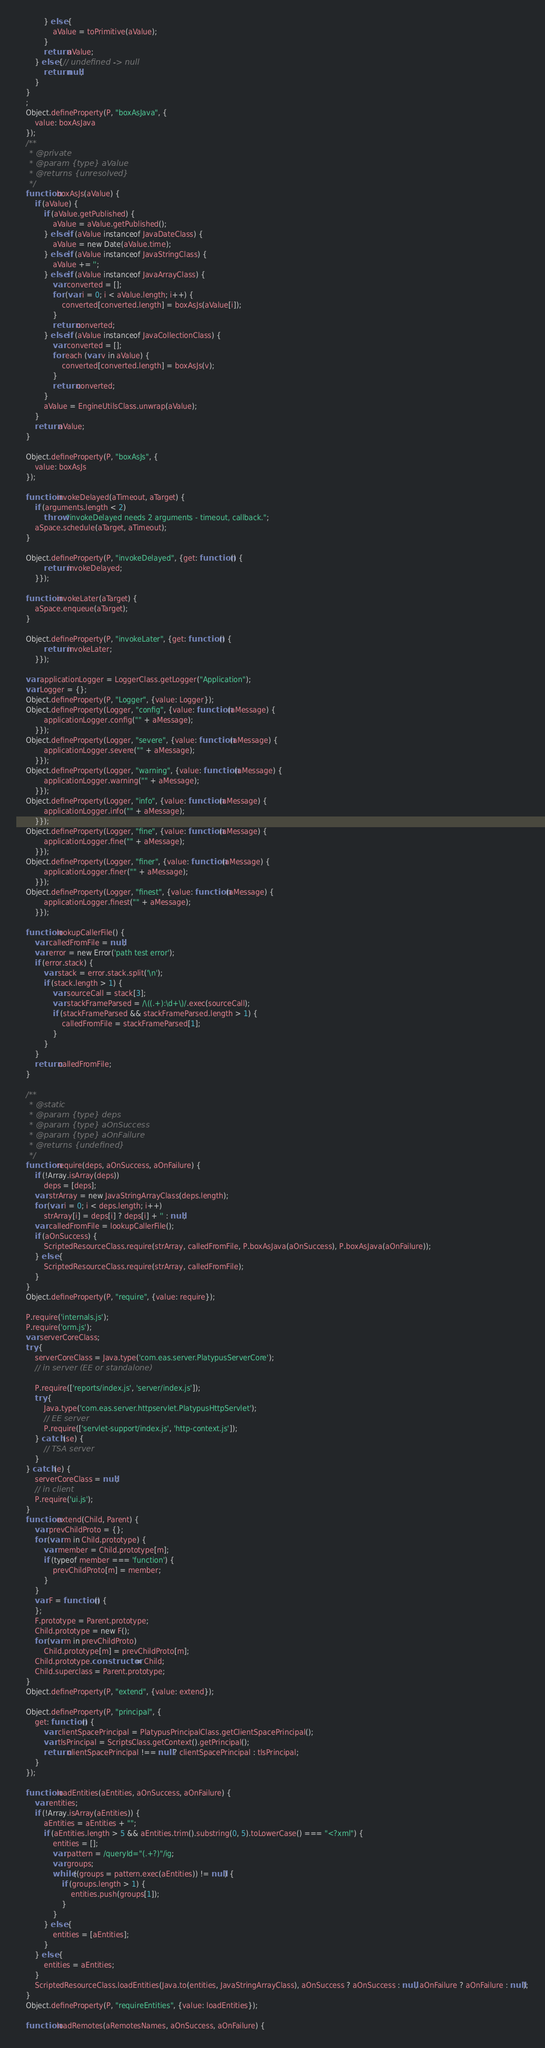<code> <loc_0><loc_0><loc_500><loc_500><_JavaScript_>            } else {
                aValue = toPrimitive(aValue);
            }
            return aValue;
        } else {// undefined -> null
            return null;
        }
    }
    ;
    Object.defineProperty(P, "boxAsJava", {
        value: boxAsJava
    });
    /**
     * @private
     * @param {type} aValue
     * @returns {unresolved}
     */
    function boxAsJs(aValue) {
        if (aValue) {
            if (aValue.getPublished) {
                aValue = aValue.getPublished();
            } else if (aValue instanceof JavaDateClass) {
                aValue = new Date(aValue.time);
            } else if (aValue instanceof JavaStringClass) {
                aValue += '';
            } else if (aValue instanceof JavaArrayClass) {
                var converted = [];
                for (var i = 0; i < aValue.length; i++) {
                    converted[converted.length] = boxAsJs(aValue[i]);
                }
                return converted;
            } else if (aValue instanceof JavaCollectionClass) {
                var converted = [];
                for each (var v in aValue) {
                    converted[converted.length] = boxAsJs(v);
                }
                return converted;
            }
            aValue = EngineUtilsClass.unwrap(aValue);
        }
        return aValue;
    }

    Object.defineProperty(P, "boxAsJs", {
        value: boxAsJs
    });

    function invokeDelayed(aTimeout, aTarget) {
        if (arguments.length < 2)
            throw "invokeDelayed needs 2 arguments - timeout, callback.";
        aSpace.schedule(aTarget, aTimeout);
    }

    Object.defineProperty(P, "invokeDelayed", {get: function () {
            return invokeDelayed;
        }});

    function invokeLater(aTarget) {
        aSpace.enqueue(aTarget);
    }

    Object.defineProperty(P, "invokeLater", {get: function () {
            return invokeLater;
        }});

    var applicationLogger = LoggerClass.getLogger("Application");
    var Logger = {};
    Object.defineProperty(P, "Logger", {value: Logger});
    Object.defineProperty(Logger, "config", {value: function (aMessage) {
            applicationLogger.config("" + aMessage);
        }});
    Object.defineProperty(Logger, "severe", {value: function (aMessage) {
            applicationLogger.severe("" + aMessage);
        }});
    Object.defineProperty(Logger, "warning", {value: function (aMessage) {
            applicationLogger.warning("" + aMessage);
        }});
    Object.defineProperty(Logger, "info", {value: function (aMessage) {
            applicationLogger.info("" + aMessage);
        }});
    Object.defineProperty(Logger, "fine", {value: function (aMessage) {
            applicationLogger.fine("" + aMessage);
        }});
    Object.defineProperty(Logger, "finer", {value: function (aMessage) {
            applicationLogger.finer("" + aMessage);
        }});
    Object.defineProperty(Logger, "finest", {value: function (aMessage) {
            applicationLogger.finest("" + aMessage);
        }});

    function lookupCallerFile() {
        var calledFromFile = null;
        var error = new Error('path test error');
        if (error.stack) {
            var stack = error.stack.split('\n');
            if (stack.length > 1) {
                var sourceCall = stack[3];
                var stackFrameParsed = /\((.+):\d+\)/.exec(sourceCall);
                if (stackFrameParsed && stackFrameParsed.length > 1) {
                    calledFromFile = stackFrameParsed[1];
                }
            }
        }
        return calledFromFile;
    }

    /**
     * @static
     * @param {type} deps
     * @param {type} aOnSuccess
     * @param {type} aOnFailure
     * @returns {undefined}
     */
    function require(deps, aOnSuccess, aOnFailure) {
        if (!Array.isArray(deps))
            deps = [deps];
        var strArray = new JavaStringArrayClass(deps.length);
        for (var i = 0; i < deps.length; i++)
            strArray[i] = deps[i] ? deps[i] + '' : null;
        var calledFromFile = lookupCallerFile();
        if (aOnSuccess) {
            ScriptedResourceClass.require(strArray, calledFromFile, P.boxAsJava(aOnSuccess), P.boxAsJava(aOnFailure));
        } else {
            ScriptedResourceClass.require(strArray, calledFromFile);
        }
    }
    Object.defineProperty(P, "require", {value: require});

    P.require('internals.js');
    P.require('orm.js');
    var serverCoreClass;
    try {
        serverCoreClass = Java.type('com.eas.server.PlatypusServerCore');
        // in server (EE or standalone)

        P.require(['reports/index.js', 'server/index.js']);
        try {
            Java.type('com.eas.server.httpservlet.PlatypusHttpServlet');
            // EE server
            P.require(['servlet-support/index.js', 'http-context.js']);
        } catch (se) {
            // TSA server
        }
    } catch (e) {
        serverCoreClass = null;
        // in client
        P.require('ui.js');
    }
    function extend(Child, Parent) {
        var prevChildProto = {};
        for (var m in Child.prototype) {
            var member = Child.prototype[m];
            if (typeof member === 'function') {
                prevChildProto[m] = member;
            }
        }
        var F = function () {
        };
        F.prototype = Parent.prototype;
        Child.prototype = new F();
        for (var m in prevChildProto)
            Child.prototype[m] = prevChildProto[m];
        Child.prototype.constructor = Child;
        Child.superclass = Parent.prototype;
    }
    Object.defineProperty(P, "extend", {value: extend});

    Object.defineProperty(P, "principal", {
        get: function () {
            var clientSpacePrincipal = PlatypusPrincipalClass.getClientSpacePrincipal();
            var tlsPrincipal = ScriptsClass.getContext().getPrincipal();
            return clientSpacePrincipal !== null ? clientSpacePrincipal : tlsPrincipal;
        }
    });

    function loadEntities(aEntities, aOnSuccess, aOnFailure) {
        var entities;
        if (!Array.isArray(aEntities)) {
            aEntities = aEntities + "";
            if (aEntities.length > 5 && aEntities.trim().substring(0, 5).toLowerCase() === "<?xml") {
                entities = [];
                var pattern = /queryId="(.+?)"/ig;
                var groups;
                while ((groups = pattern.exec(aEntities)) != null) {
                    if (groups.length > 1) {
                        entities.push(groups[1]);
                    }
                }
            } else {
                entities = [aEntities];
            }
        } else {
            entities = aEntities;
        }
        ScriptedResourceClass.loadEntities(Java.to(entities, JavaStringArrayClass), aOnSuccess ? aOnSuccess : null, aOnFailure ? aOnFailure : null);
    }
    Object.defineProperty(P, "requireEntities", {value: loadEntities});

    function loadRemotes(aRemotesNames, aOnSuccess, aOnFailure) {</code> 